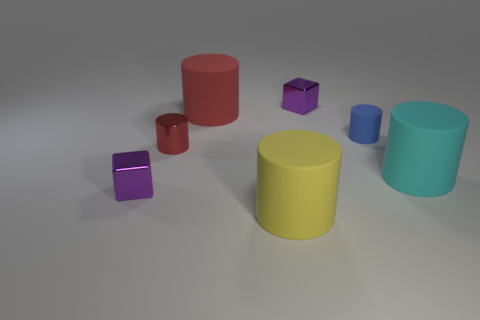Subtract all blue rubber cylinders. How many cylinders are left? 4 Subtract 4 cylinders. How many cylinders are left? 1 Add 1 purple metal things. How many objects exist? 8 Subtract all cylinders. How many objects are left? 2 Subtract all cyan cylinders. How many cylinders are left? 4 Subtract all purple cylinders. Subtract all blue balls. How many cylinders are left? 5 Subtract all purple spheres. How many gray blocks are left? 0 Subtract all big matte objects. Subtract all cyan matte cylinders. How many objects are left? 3 Add 2 tiny shiny cubes. How many tiny shiny cubes are left? 4 Add 6 small purple matte cylinders. How many small purple matte cylinders exist? 6 